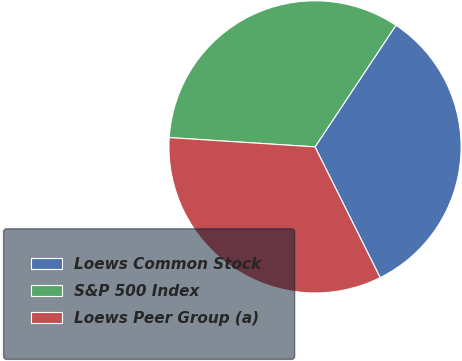Convert chart. <chart><loc_0><loc_0><loc_500><loc_500><pie_chart><fcel>Loews Common Stock<fcel>S&P 500 Index<fcel>Loews Peer Group (a)<nl><fcel>33.3%<fcel>33.33%<fcel>33.37%<nl></chart> 